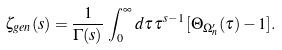Convert formula to latex. <formula><loc_0><loc_0><loc_500><loc_500>\zeta _ { g e n } ( s ) = \frac { 1 } { \Gamma ( s ) } \, \int _ { 0 } ^ { \infty } d \tau \, \tau ^ { s - 1 } \, [ \Theta _ { \Omega ^ { \prime } _ { n } } ( \tau ) - 1 ] .</formula> 